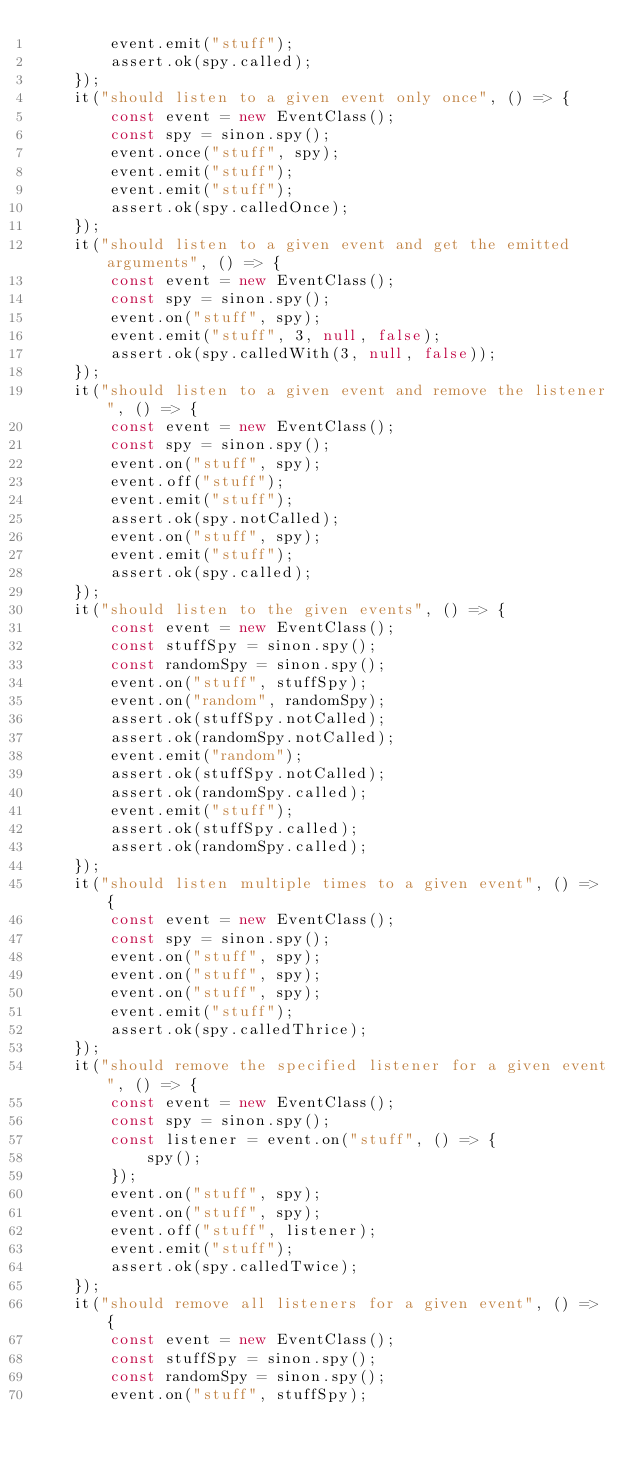<code> <loc_0><loc_0><loc_500><loc_500><_JavaScript_>        event.emit("stuff");
        assert.ok(spy.called);
    });
    it("should listen to a given event only once", () => {
        const event = new EventClass();
        const spy = sinon.spy();
        event.once("stuff", spy);
        event.emit("stuff");
        event.emit("stuff");
        assert.ok(spy.calledOnce);
    });
    it("should listen to a given event and get the emitted arguments", () => {
        const event = new EventClass();
        const spy = sinon.spy();
        event.on("stuff", spy);
        event.emit("stuff", 3, null, false);
        assert.ok(spy.calledWith(3, null, false));
    });
    it("should listen to a given event and remove the listener", () => {
        const event = new EventClass();
        const spy = sinon.spy();
        event.on("stuff", spy);
        event.off("stuff");
        event.emit("stuff");
        assert.ok(spy.notCalled);
        event.on("stuff", spy);
        event.emit("stuff");
        assert.ok(spy.called);
    });
    it("should listen to the given events", () => {
        const event = new EventClass();
        const stuffSpy = sinon.spy();
        const randomSpy = sinon.spy();
        event.on("stuff", stuffSpy);
        event.on("random", randomSpy);
        assert.ok(stuffSpy.notCalled);
        assert.ok(randomSpy.notCalled);
        event.emit("random");
        assert.ok(stuffSpy.notCalled);
        assert.ok(randomSpy.called);
        event.emit("stuff");
        assert.ok(stuffSpy.called);
        assert.ok(randomSpy.called);
    });
    it("should listen multiple times to a given event", () => {
        const event = new EventClass();
        const spy = sinon.spy();
        event.on("stuff", spy);
        event.on("stuff", spy);
        event.on("stuff", spy);
        event.emit("stuff");
        assert.ok(spy.calledThrice);
    });
    it("should remove the specified listener for a given event", () => {
        const event = new EventClass();
        const spy = sinon.spy();
        const listener = event.on("stuff", () => {
            spy();
        });
        event.on("stuff", spy);
        event.on("stuff", spy);
        event.off("stuff", listener);
        event.emit("stuff");
        assert.ok(spy.calledTwice);
    });
    it("should remove all listeners for a given event", () => {
        const event = new EventClass();
        const stuffSpy = sinon.spy();
        const randomSpy = sinon.spy();
        event.on("stuff", stuffSpy);</code> 